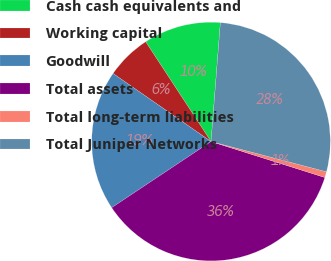Convert chart to OTSL. <chart><loc_0><loc_0><loc_500><loc_500><pie_chart><fcel>Cash cash equivalents and<fcel>Working capital<fcel>Goodwill<fcel>Total assets<fcel>Total long-term liabilities<fcel>Total Juniper Networks<nl><fcel>10.48%<fcel>6.11%<fcel>19.01%<fcel>35.79%<fcel>0.79%<fcel>27.83%<nl></chart> 